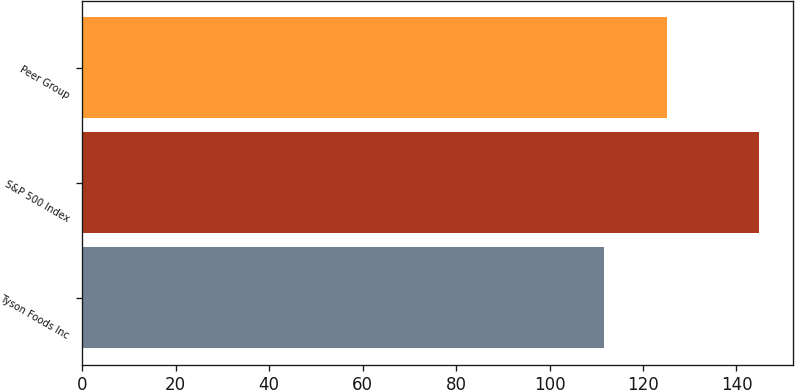Convert chart. <chart><loc_0><loc_0><loc_500><loc_500><bar_chart><fcel>Tyson Foods Inc<fcel>S&P 500 Index<fcel>Peer Group<nl><fcel>111.59<fcel>144.81<fcel>125.17<nl></chart> 